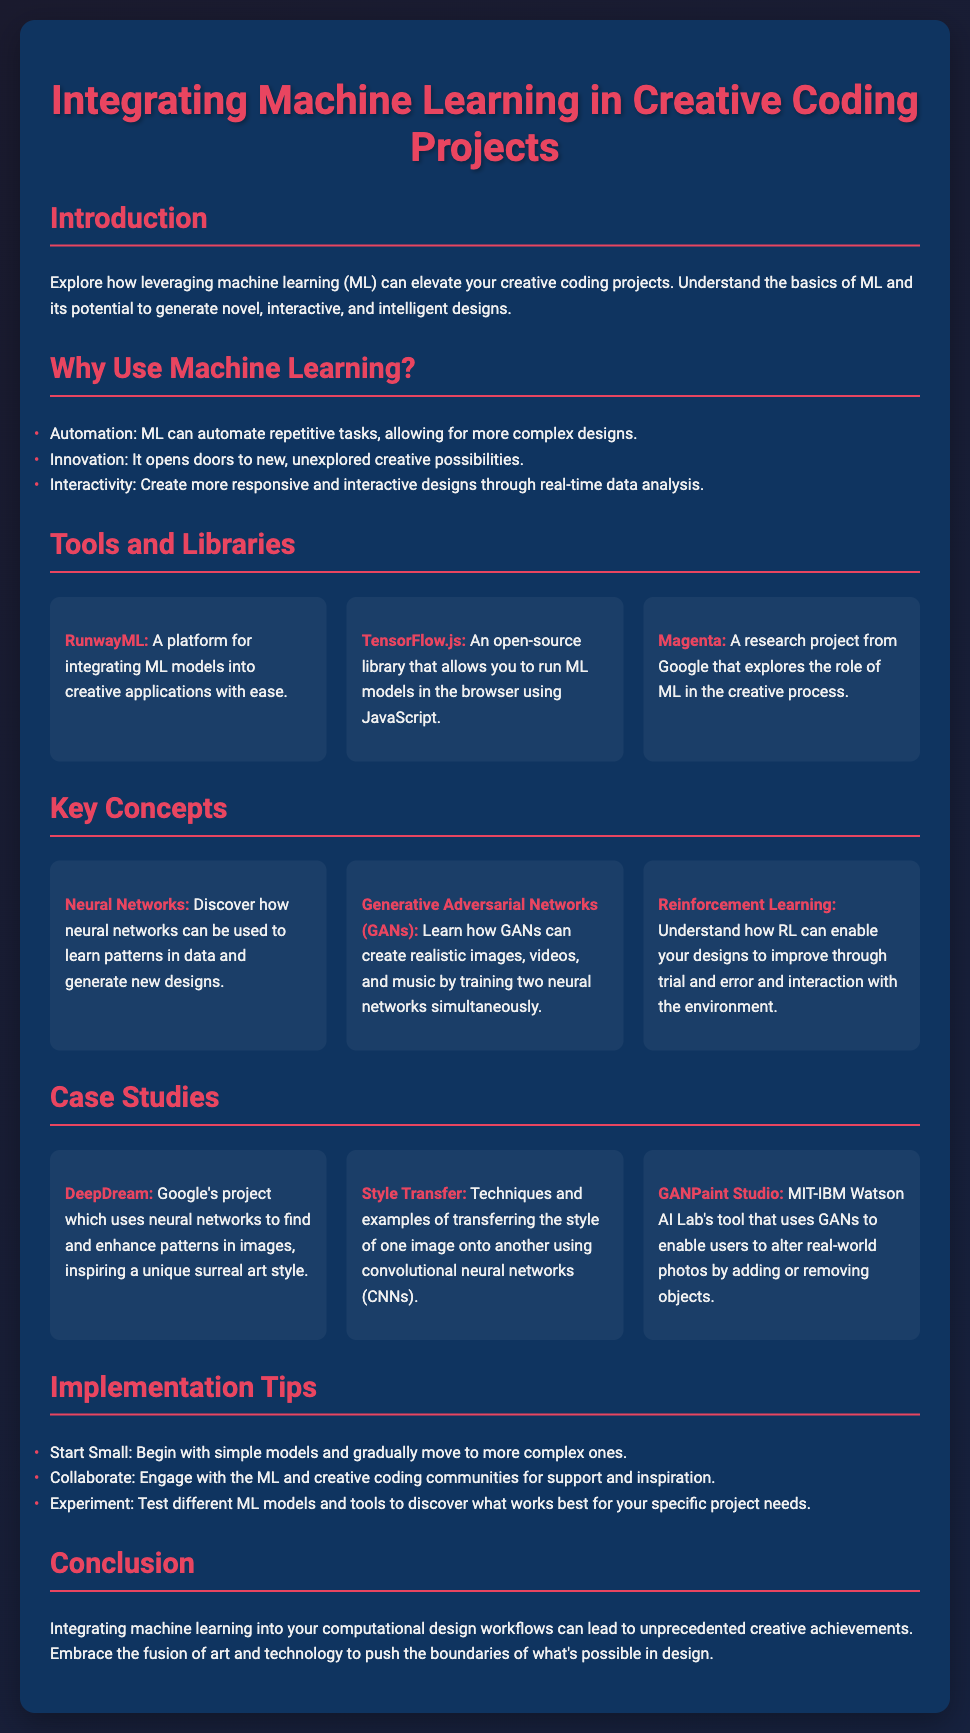What is the title of the presentation? The title is prominently featured at the top of the slide.
Answer: Integrating Machine Learning in Creative Coding Projects What are the three key benefits of using machine learning listed? The benefits are highlighted in a bulleted list under the relevant section.
Answer: Automation, Innovation, Interactivity Which tool is described as a platform for integrating ML models? This information is found in the section about tools and libraries.
Answer: RunwayML What are the three types of key concepts discussed in the presentation? The concepts are introduced in the relevant section and outlined through bold text.
Answer: Neural Networks, Generative Adversarial Networks, Reinforcement Learning Who created the DeepDream project? The information can be found in the case studies section detailing its background.
Answer: Google What kind of neural networks are used in style transfer? This detail is mentioned while explaining the technique used for style transfer.
Answer: Convolutional Neural Networks What is one implementation tip provided? Tips are listed under a specific section focused on implementation advice for users.
Answer: Start Small How many case studies are presented? The number of case studies is counted in the specified section of the slide.
Answer: Three 